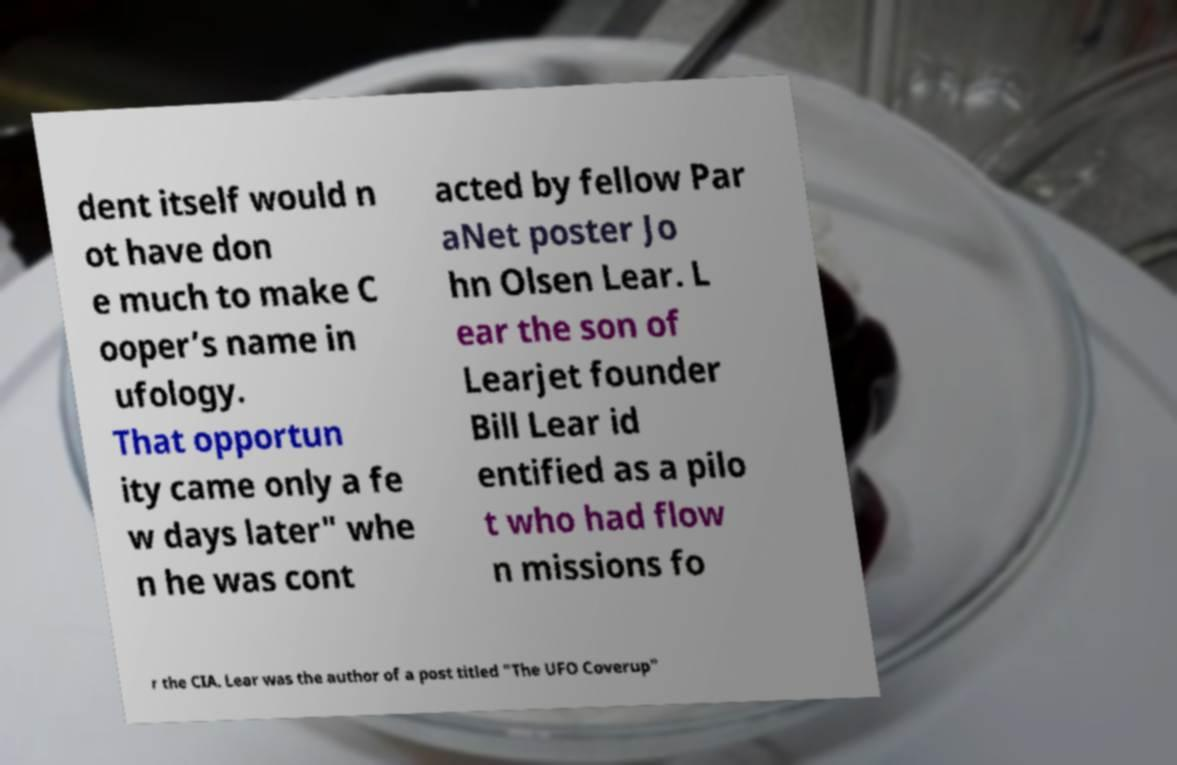Please identify and transcribe the text found in this image. dent itself would n ot have don e much to make C ooper’s name in ufology. That opportun ity came only a fe w days later" whe n he was cont acted by fellow Par aNet poster Jo hn Olsen Lear. L ear the son of Learjet founder Bill Lear id entified as a pilo t who had flow n missions fo r the CIA. Lear was the author of a post titled "The UFO Coverup" 